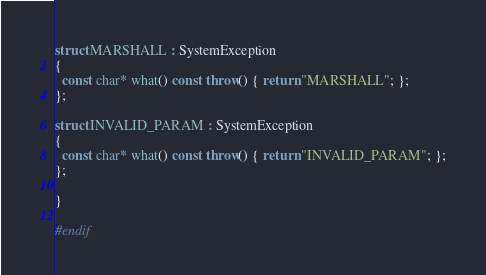<code> <loc_0><loc_0><loc_500><loc_500><_C++_>
struct MARSHALL : SystemException
{
  const char* what() const throw() { return "MARSHALL"; };
};

struct INVALID_PARAM : SystemException
{
  const char* what() const throw() { return "INVALID_PARAM"; };
};

}

#endif
</code> 